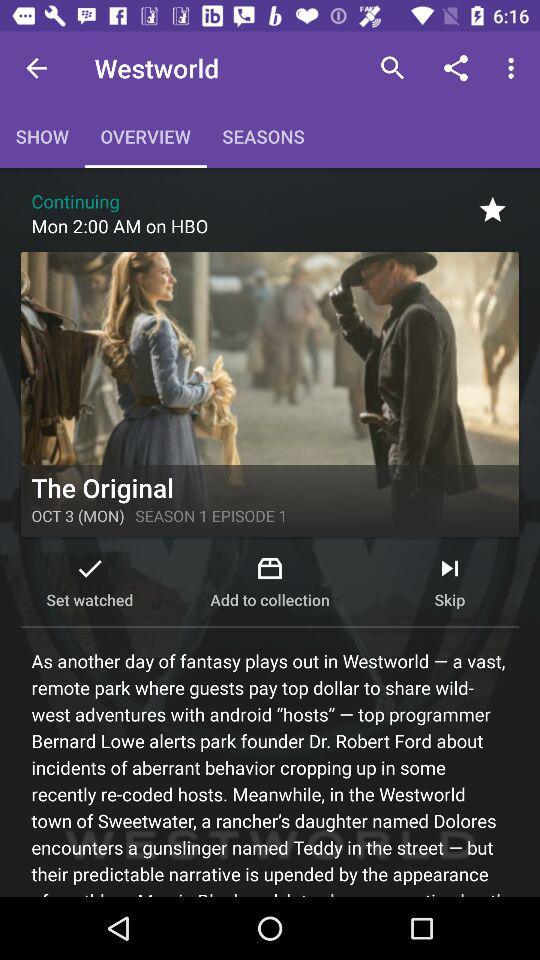What date is given? The given date is Monday, October 3. 